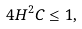Convert formula to latex. <formula><loc_0><loc_0><loc_500><loc_500>4 H ^ { 2 } C \leq 1 ,</formula> 